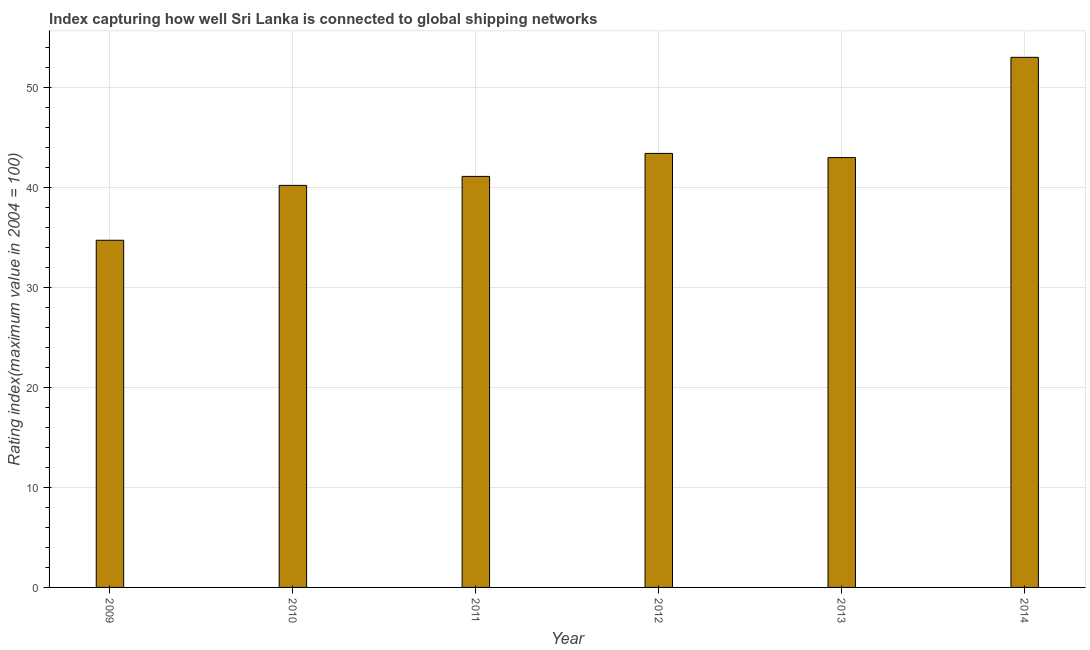What is the title of the graph?
Provide a short and direct response. Index capturing how well Sri Lanka is connected to global shipping networks. What is the label or title of the Y-axis?
Offer a very short reply. Rating index(maximum value in 2004 = 100). What is the liner shipping connectivity index in 2009?
Keep it short and to the point. 34.74. Across all years, what is the maximum liner shipping connectivity index?
Make the answer very short. 53.04. Across all years, what is the minimum liner shipping connectivity index?
Provide a succinct answer. 34.74. In which year was the liner shipping connectivity index maximum?
Provide a short and direct response. 2014. In which year was the liner shipping connectivity index minimum?
Offer a very short reply. 2009. What is the sum of the liner shipping connectivity index?
Offer a very short reply. 255.58. What is the difference between the liner shipping connectivity index in 2009 and 2014?
Provide a succinct answer. -18.3. What is the average liner shipping connectivity index per year?
Offer a very short reply. 42.6. What is the median liner shipping connectivity index?
Offer a very short reply. 42.07. Do a majority of the years between 2009 and 2013 (inclusive) have liner shipping connectivity index greater than 18 ?
Make the answer very short. Yes. What is the ratio of the liner shipping connectivity index in 2009 to that in 2014?
Make the answer very short. 0.66. Is the difference between the liner shipping connectivity index in 2012 and 2014 greater than the difference between any two years?
Provide a short and direct response. No. What is the difference between the highest and the second highest liner shipping connectivity index?
Your response must be concise. 9.61. Is the sum of the liner shipping connectivity index in 2010 and 2013 greater than the maximum liner shipping connectivity index across all years?
Ensure brevity in your answer.  Yes. Are all the bars in the graph horizontal?
Provide a short and direct response. No. What is the difference between two consecutive major ticks on the Y-axis?
Keep it short and to the point. 10. Are the values on the major ticks of Y-axis written in scientific E-notation?
Provide a short and direct response. No. What is the Rating index(maximum value in 2004 = 100) in 2009?
Your answer should be very brief. 34.74. What is the Rating index(maximum value in 2004 = 100) of 2010?
Ensure brevity in your answer.  40.23. What is the Rating index(maximum value in 2004 = 100) of 2011?
Ensure brevity in your answer.  41.13. What is the Rating index(maximum value in 2004 = 100) of 2012?
Your answer should be very brief. 43.43. What is the Rating index(maximum value in 2004 = 100) in 2013?
Your answer should be compact. 43.01. What is the Rating index(maximum value in 2004 = 100) of 2014?
Provide a short and direct response. 53.04. What is the difference between the Rating index(maximum value in 2004 = 100) in 2009 and 2010?
Your answer should be compact. -5.49. What is the difference between the Rating index(maximum value in 2004 = 100) in 2009 and 2011?
Keep it short and to the point. -6.39. What is the difference between the Rating index(maximum value in 2004 = 100) in 2009 and 2012?
Give a very brief answer. -8.69. What is the difference between the Rating index(maximum value in 2004 = 100) in 2009 and 2013?
Make the answer very short. -8.27. What is the difference between the Rating index(maximum value in 2004 = 100) in 2009 and 2014?
Ensure brevity in your answer.  -18.3. What is the difference between the Rating index(maximum value in 2004 = 100) in 2010 and 2011?
Ensure brevity in your answer.  -0.9. What is the difference between the Rating index(maximum value in 2004 = 100) in 2010 and 2013?
Keep it short and to the point. -2.78. What is the difference between the Rating index(maximum value in 2004 = 100) in 2010 and 2014?
Ensure brevity in your answer.  -12.81. What is the difference between the Rating index(maximum value in 2004 = 100) in 2011 and 2012?
Give a very brief answer. -2.3. What is the difference between the Rating index(maximum value in 2004 = 100) in 2011 and 2013?
Your answer should be compact. -1.88. What is the difference between the Rating index(maximum value in 2004 = 100) in 2011 and 2014?
Ensure brevity in your answer.  -11.91. What is the difference between the Rating index(maximum value in 2004 = 100) in 2012 and 2013?
Your response must be concise. 0.42. What is the difference between the Rating index(maximum value in 2004 = 100) in 2012 and 2014?
Make the answer very short. -9.61. What is the difference between the Rating index(maximum value in 2004 = 100) in 2013 and 2014?
Offer a terse response. -10.03. What is the ratio of the Rating index(maximum value in 2004 = 100) in 2009 to that in 2010?
Give a very brief answer. 0.86. What is the ratio of the Rating index(maximum value in 2004 = 100) in 2009 to that in 2011?
Offer a very short reply. 0.84. What is the ratio of the Rating index(maximum value in 2004 = 100) in 2009 to that in 2013?
Keep it short and to the point. 0.81. What is the ratio of the Rating index(maximum value in 2004 = 100) in 2009 to that in 2014?
Give a very brief answer. 0.66. What is the ratio of the Rating index(maximum value in 2004 = 100) in 2010 to that in 2012?
Offer a very short reply. 0.93. What is the ratio of the Rating index(maximum value in 2004 = 100) in 2010 to that in 2013?
Provide a short and direct response. 0.94. What is the ratio of the Rating index(maximum value in 2004 = 100) in 2010 to that in 2014?
Your answer should be compact. 0.76. What is the ratio of the Rating index(maximum value in 2004 = 100) in 2011 to that in 2012?
Ensure brevity in your answer.  0.95. What is the ratio of the Rating index(maximum value in 2004 = 100) in 2011 to that in 2013?
Keep it short and to the point. 0.96. What is the ratio of the Rating index(maximum value in 2004 = 100) in 2011 to that in 2014?
Ensure brevity in your answer.  0.78. What is the ratio of the Rating index(maximum value in 2004 = 100) in 2012 to that in 2013?
Your response must be concise. 1.01. What is the ratio of the Rating index(maximum value in 2004 = 100) in 2012 to that in 2014?
Keep it short and to the point. 0.82. What is the ratio of the Rating index(maximum value in 2004 = 100) in 2013 to that in 2014?
Ensure brevity in your answer.  0.81. 